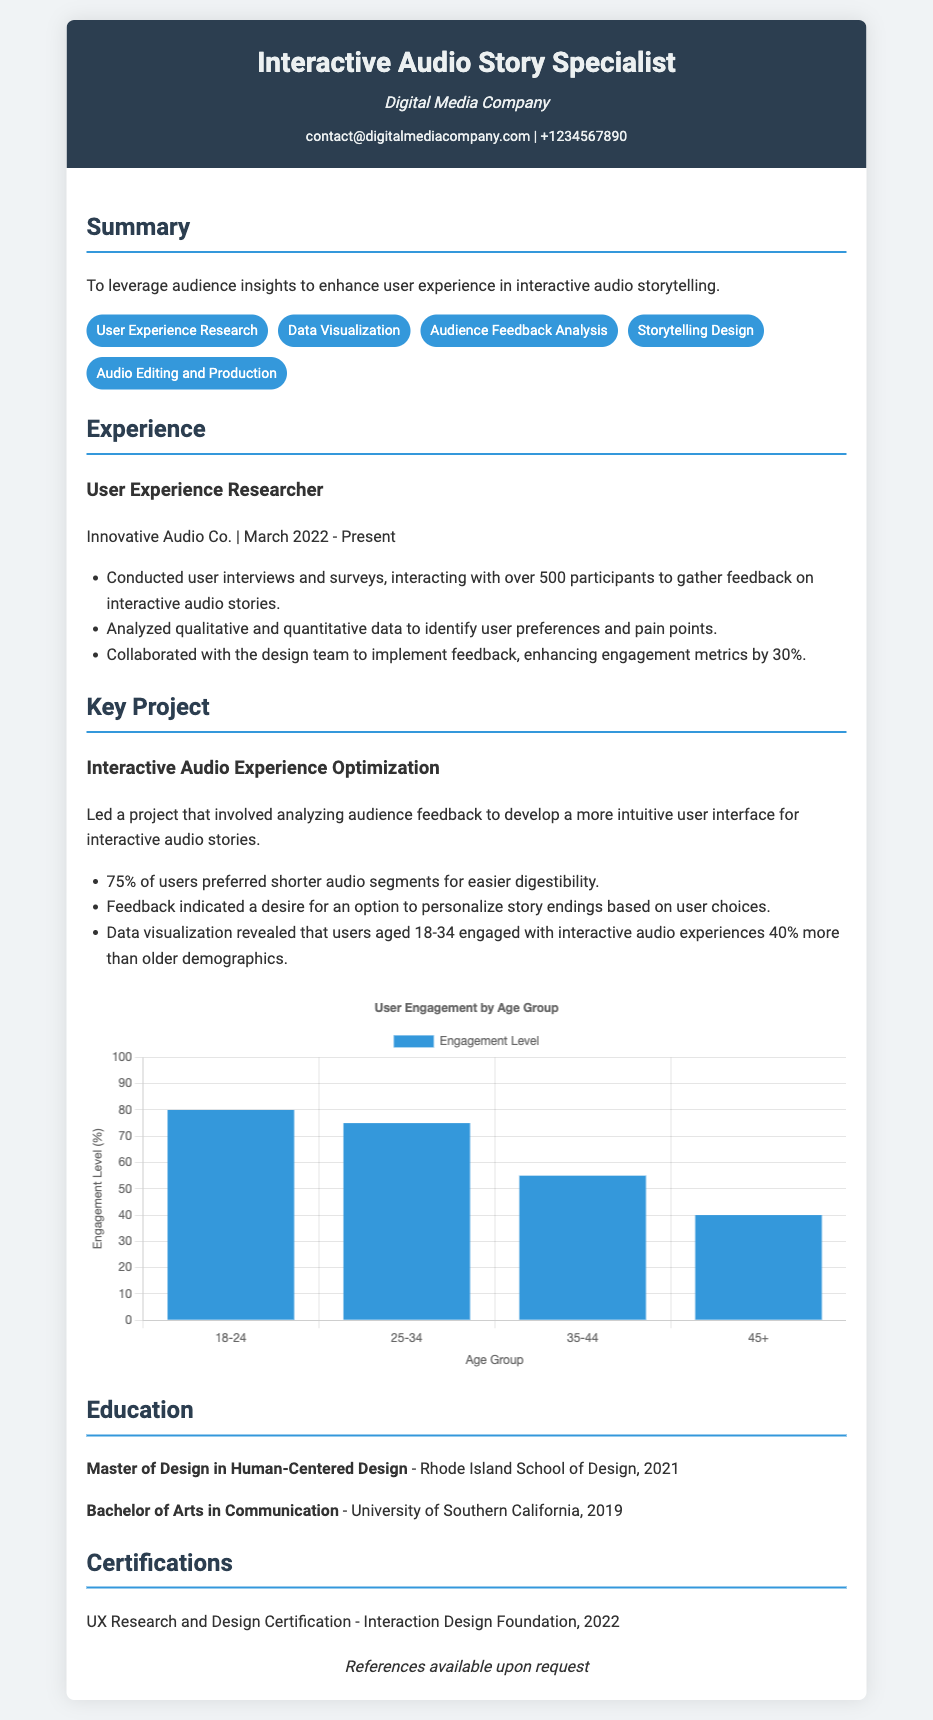what is the title of the document? The title of the document is stated prominently at the top, which is "Interactive Audio Story Specialist Resume."
Answer: Interactive Audio Story Specialist Resume who is the current employer listed? The current employer mentioned in the experience section is Innovative Audio Co.
Answer: Innovative Audio Co what percentage of users preferred shorter audio segments? The document notes that 75% of users preferred shorter audio segments for easier digestibility.
Answer: 75% how many participants were involved in user interviews and surveys? The document states that over 500 participants were involved in gathering feedback through user interviews and surveys.
Answer: Over 500 which age group has the highest engagement level? According to the visual data, the 18-24 age group has the highest engagement level.
Answer: 18-24 what is the main focus of the summary section? The summary section emphasizes leveraging audience insights to enhance user experience in interactive audio storytelling.
Answer: Audience insights what is one desired feature indicated by user feedback? Users expressed a desire for an option to personalize story endings based on user choices.
Answer: Personalize story endings what type of chart is used in the document? The chart type presented for user engagement is a bar chart.
Answer: Bar chart which certification was obtained in 2022? The certification mentioned in the document that was obtained in 2022 is UX Research and Design Certification.
Answer: UX Research and Design Certification 